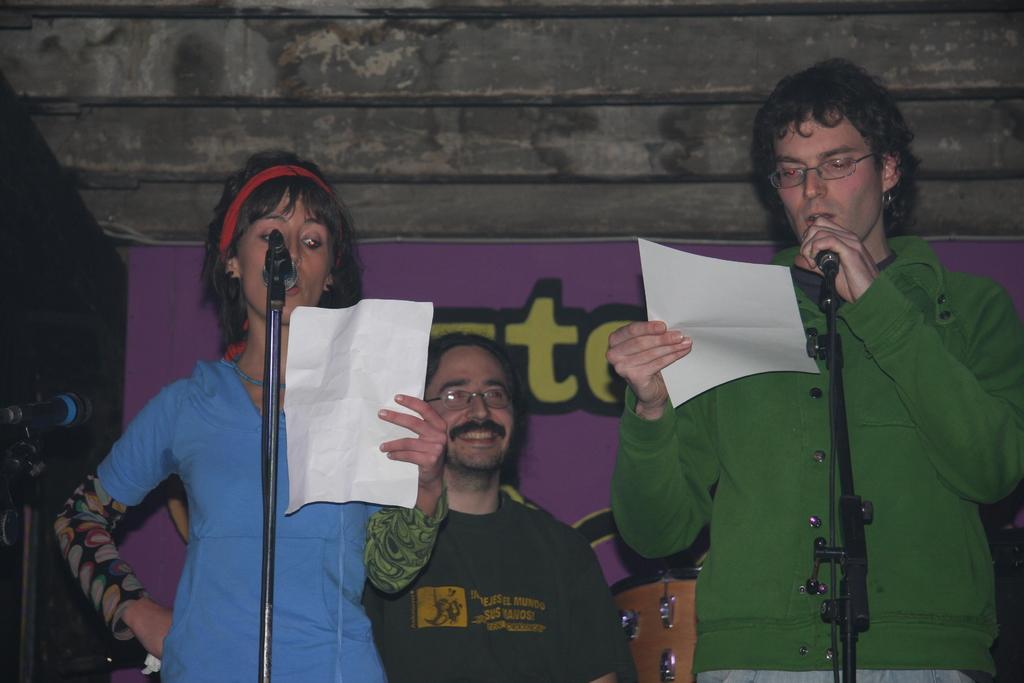Describe this image in one or two sentences. In the middle of the image there are some microphones. Behind the microphones few people are standing and holding some papers. Behind them there is a banner and wall. 